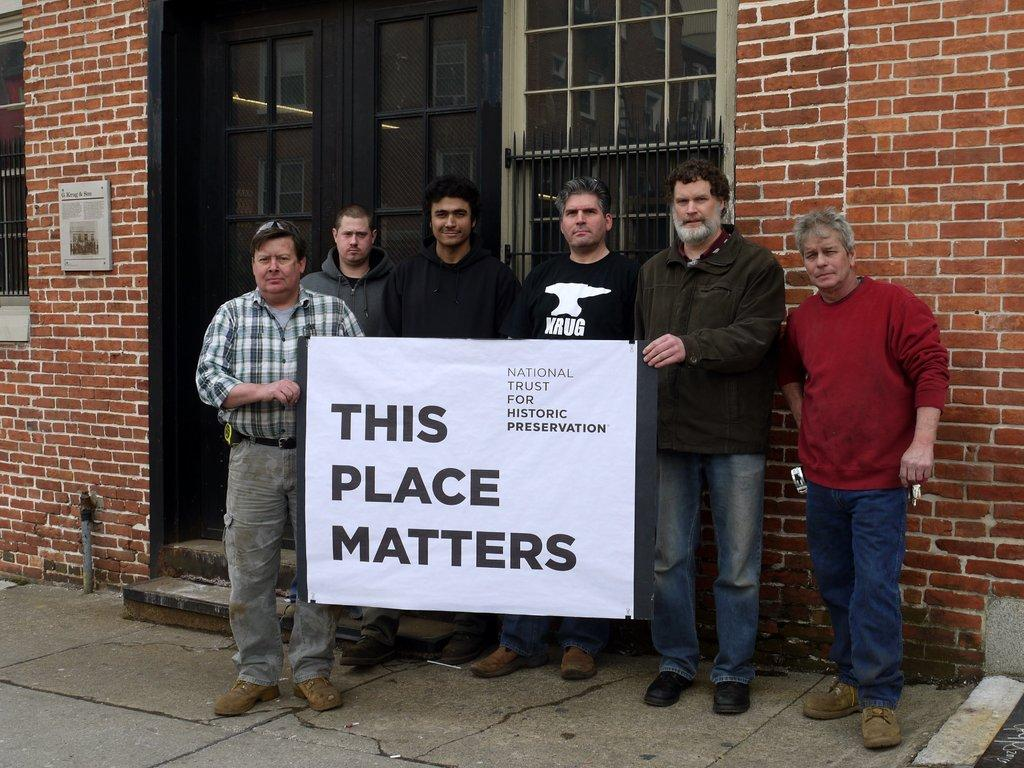What are the people in the image doing? The people in the image are standing in the middle of the image. What are the people holding in the image? The people are holding a banner in the image. What architectural features can be seen in the background of the image? There are doors, windows, and walls visible in the background of the image. How many chickens can be seen running on the train in the image? There are no chickens or trains present in the image. 